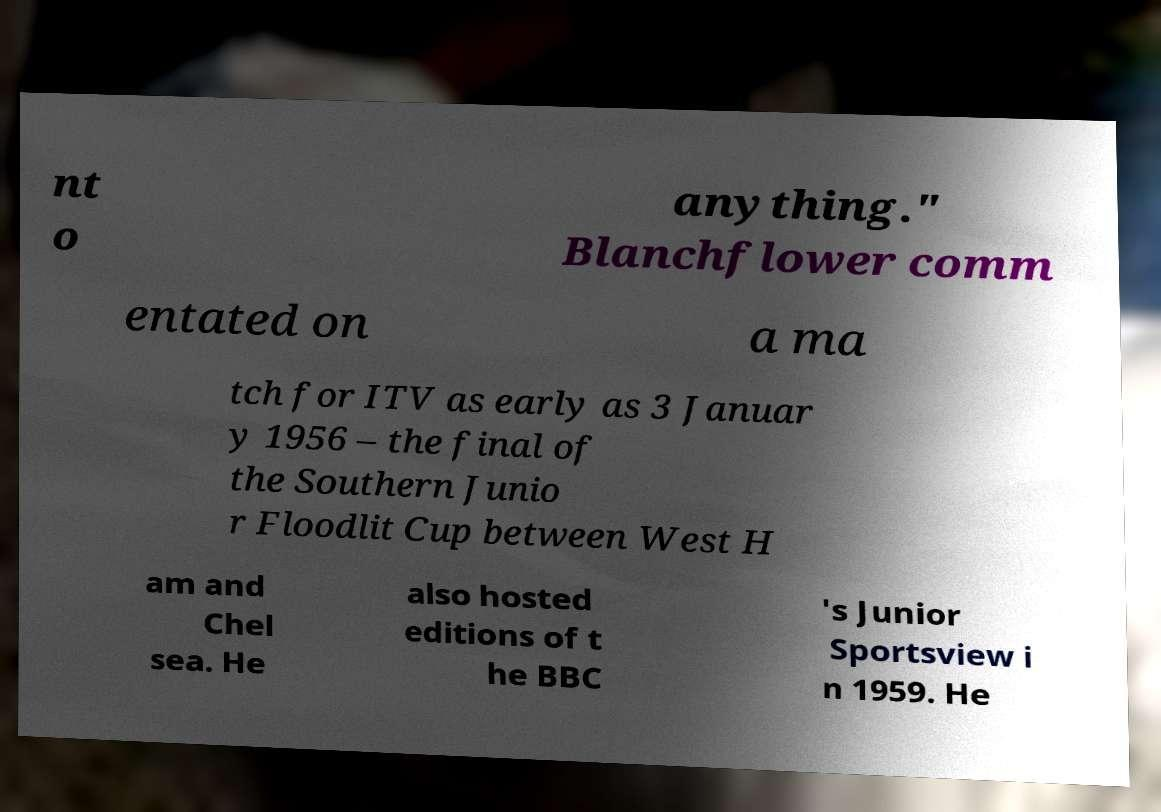What messages or text are displayed in this image? I need them in a readable, typed format. nt o anything." Blanchflower comm entated on a ma tch for ITV as early as 3 Januar y 1956 – the final of the Southern Junio r Floodlit Cup between West H am and Chel sea. He also hosted editions of t he BBC 's Junior Sportsview i n 1959. He 